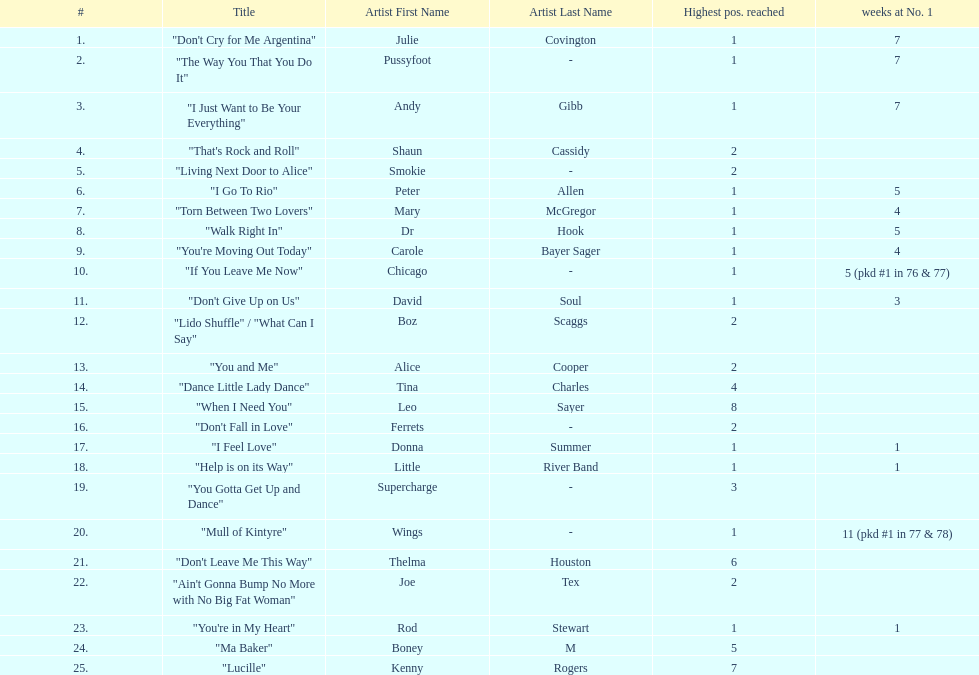Which three artists had a single at number 1 for at least 7 weeks on the australian singles charts in 1977? Julie Covington, Pussyfoot, Andy Gibb. 